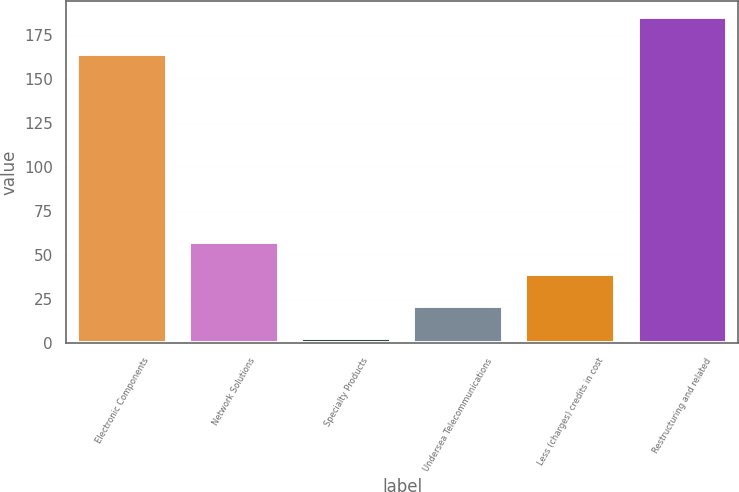<chart> <loc_0><loc_0><loc_500><loc_500><bar_chart><fcel>Electronic Components<fcel>Network Solutions<fcel>Specialty Products<fcel>Undersea Telecommunications<fcel>Less (charges) credits in cost<fcel>Restructuring and related<nl><fcel>164<fcel>57.6<fcel>3<fcel>21.2<fcel>39.4<fcel>185<nl></chart> 